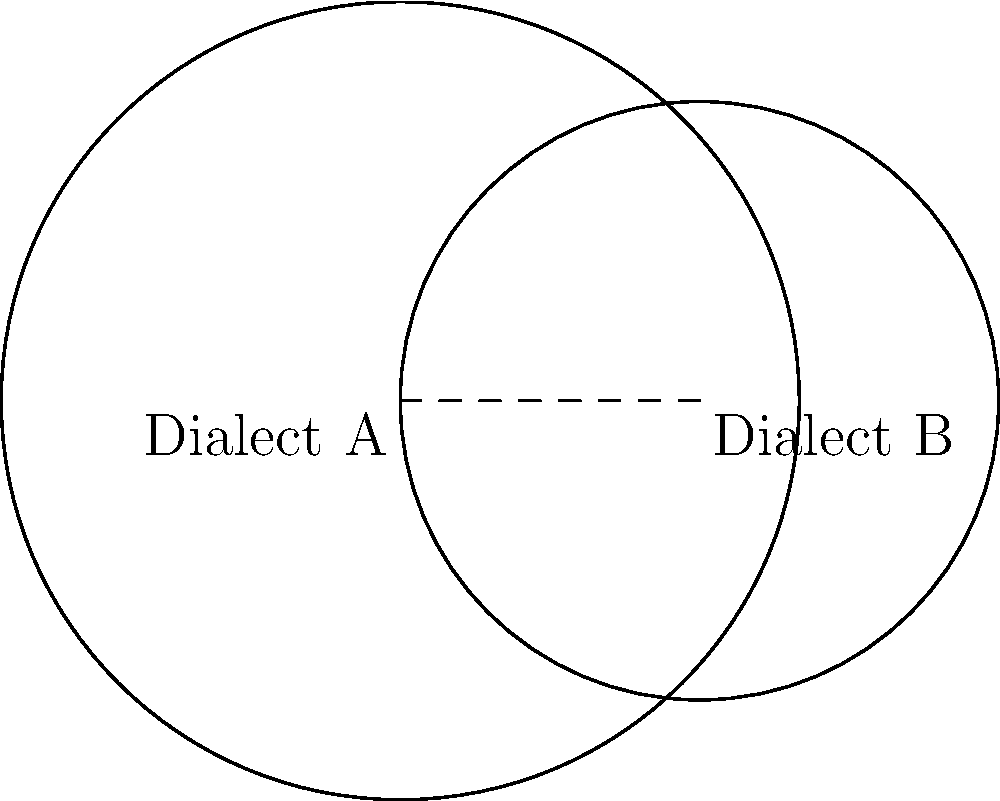In your linguistic research, you've mapped the spread of two dialects as overlapping circular regions. Dialect A has a radius of 4 units, while Dialect B has a radius of 3 units. The centers of these circles are 3 units apart. Calculate the area of the region where these dialects overlap, representing the area where both dialects are spoken. Round your answer to two decimal places. To find the area of overlap between two circles, we'll use the formula for the area of intersection of two circles. Let's approach this step-by-step:

1) First, we need to calculate the distance (d) between the centers of the circles:
   d = 3 (given in the question)

2) We have:
   r1 = 4 (radius of Dialect A)
   r2 = 3 (radius of Dialect B)

3) To use the formula, we need to check if the circles intersect:
   r1 + r2 > d > |r1 - r2|
   7 > 3 > 1
   This condition is satisfied, so the circles do intersect.

4) Now we can use the formula for the area of intersection:

   $$ A = r_1^2 \arccos(\frac{d^2 + r_1^2 - r_2^2}{2dr_1}) + r_2^2 \arccos(\frac{d^2 + r_2^2 - r_1^2}{2dr_2}) - \frac{1}{2}\sqrt{(-d+r_1+r_2)(d+r_1-r_2)(d-r_1+r_2)(d+r_1+r_2)} $$

5) Let's calculate each part:

   $$ \arccos(\frac{3^2 + 4^2 - 3^2}{2 * 3 * 4}) = \arccos(\frac{25}{24}) = 0.2838 \text{ radians} $$
   $$ \arccos(\frac{3^2 + 3^2 - 4^2}{2 * 3 * 3}) = \arccos(\frac{2}{6}) = 1.2870 \text{ radians} $$
   $$ \sqrt{(-3+4+3)(3+4-3)(3-4+3)(3+4+3)} = \sqrt{4 * 4 * 2 * 10} = 8\sqrt{5} $$

6) Putting it all together:

   $$ A = 4^2 * 0.2838 + 3^2 * 1.2870 - \frac{1}{2} * 8\sqrt{5} $$
   $$ A = 4.5408 + 11.5830 - 8.9443 $$
   $$ A = 7.1795 $$

7) Rounding to two decimal places: 7.18
Answer: 7.18 square units 